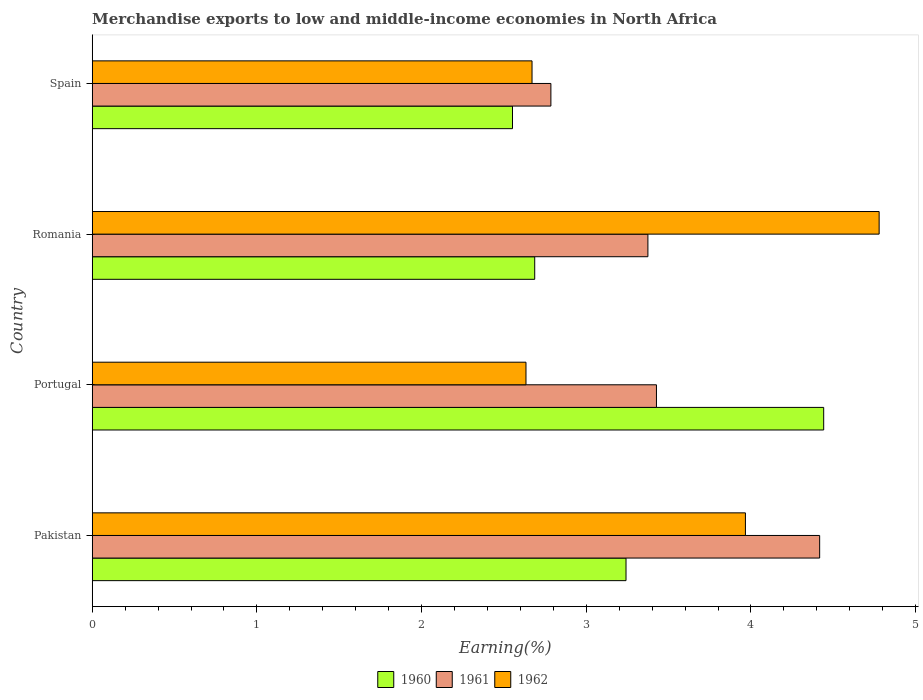How many different coloured bars are there?
Provide a succinct answer. 3. Are the number of bars per tick equal to the number of legend labels?
Your response must be concise. Yes. Are the number of bars on each tick of the Y-axis equal?
Provide a succinct answer. Yes. How many bars are there on the 1st tick from the top?
Your response must be concise. 3. How many bars are there on the 4th tick from the bottom?
Offer a very short reply. 3. What is the label of the 2nd group of bars from the top?
Provide a succinct answer. Romania. What is the percentage of amount earned from merchandise exports in 1960 in Romania?
Make the answer very short. 2.69. Across all countries, what is the maximum percentage of amount earned from merchandise exports in 1961?
Your response must be concise. 4.42. Across all countries, what is the minimum percentage of amount earned from merchandise exports in 1962?
Offer a very short reply. 2.63. What is the total percentage of amount earned from merchandise exports in 1961 in the graph?
Ensure brevity in your answer.  14. What is the difference between the percentage of amount earned from merchandise exports in 1961 in Pakistan and that in Portugal?
Offer a terse response. 0.99. What is the difference between the percentage of amount earned from merchandise exports in 1960 in Pakistan and the percentage of amount earned from merchandise exports in 1962 in Portugal?
Ensure brevity in your answer.  0.61. What is the average percentage of amount earned from merchandise exports in 1961 per country?
Your answer should be compact. 3.5. What is the difference between the percentage of amount earned from merchandise exports in 1961 and percentage of amount earned from merchandise exports in 1960 in Pakistan?
Your response must be concise. 1.18. What is the ratio of the percentage of amount earned from merchandise exports in 1960 in Pakistan to that in Spain?
Ensure brevity in your answer.  1.27. Is the percentage of amount earned from merchandise exports in 1961 in Pakistan less than that in Portugal?
Ensure brevity in your answer.  No. Is the difference between the percentage of amount earned from merchandise exports in 1961 in Pakistan and Romania greater than the difference between the percentage of amount earned from merchandise exports in 1960 in Pakistan and Romania?
Your answer should be very brief. Yes. What is the difference between the highest and the second highest percentage of amount earned from merchandise exports in 1962?
Keep it short and to the point. 0.81. What is the difference between the highest and the lowest percentage of amount earned from merchandise exports in 1962?
Provide a short and direct response. 2.14. In how many countries, is the percentage of amount earned from merchandise exports in 1960 greater than the average percentage of amount earned from merchandise exports in 1960 taken over all countries?
Keep it short and to the point. 2. What does the 1st bar from the top in Romania represents?
Your response must be concise. 1962. Is it the case that in every country, the sum of the percentage of amount earned from merchandise exports in 1960 and percentage of amount earned from merchandise exports in 1961 is greater than the percentage of amount earned from merchandise exports in 1962?
Your answer should be compact. Yes. How many countries are there in the graph?
Provide a short and direct response. 4. Does the graph contain any zero values?
Your answer should be compact. No. Does the graph contain grids?
Make the answer very short. No. Where does the legend appear in the graph?
Ensure brevity in your answer.  Bottom center. How are the legend labels stacked?
Your answer should be very brief. Horizontal. What is the title of the graph?
Your answer should be very brief. Merchandise exports to low and middle-income economies in North Africa. Does "1986" appear as one of the legend labels in the graph?
Your response must be concise. No. What is the label or title of the X-axis?
Provide a succinct answer. Earning(%). What is the label or title of the Y-axis?
Provide a short and direct response. Country. What is the Earning(%) of 1960 in Pakistan?
Offer a terse response. 3.24. What is the Earning(%) in 1961 in Pakistan?
Make the answer very short. 4.42. What is the Earning(%) in 1962 in Pakistan?
Your answer should be compact. 3.97. What is the Earning(%) in 1960 in Portugal?
Give a very brief answer. 4.44. What is the Earning(%) of 1961 in Portugal?
Your answer should be compact. 3.43. What is the Earning(%) in 1962 in Portugal?
Your answer should be very brief. 2.63. What is the Earning(%) of 1960 in Romania?
Your answer should be very brief. 2.69. What is the Earning(%) of 1961 in Romania?
Make the answer very short. 3.37. What is the Earning(%) of 1962 in Romania?
Offer a terse response. 4.78. What is the Earning(%) in 1960 in Spain?
Your response must be concise. 2.55. What is the Earning(%) in 1961 in Spain?
Keep it short and to the point. 2.79. What is the Earning(%) of 1962 in Spain?
Make the answer very short. 2.67. Across all countries, what is the maximum Earning(%) of 1960?
Your response must be concise. 4.44. Across all countries, what is the maximum Earning(%) in 1961?
Give a very brief answer. 4.42. Across all countries, what is the maximum Earning(%) in 1962?
Make the answer very short. 4.78. Across all countries, what is the minimum Earning(%) of 1960?
Offer a terse response. 2.55. Across all countries, what is the minimum Earning(%) in 1961?
Ensure brevity in your answer.  2.79. Across all countries, what is the minimum Earning(%) in 1962?
Provide a short and direct response. 2.63. What is the total Earning(%) of 1960 in the graph?
Provide a succinct answer. 12.92. What is the total Earning(%) of 1961 in the graph?
Keep it short and to the point. 14. What is the total Earning(%) of 1962 in the graph?
Offer a very short reply. 14.05. What is the difference between the Earning(%) in 1960 in Pakistan and that in Portugal?
Give a very brief answer. -1.2. What is the difference between the Earning(%) in 1962 in Pakistan and that in Portugal?
Make the answer very short. 1.33. What is the difference between the Earning(%) in 1960 in Pakistan and that in Romania?
Your response must be concise. 0.55. What is the difference between the Earning(%) of 1961 in Pakistan and that in Romania?
Keep it short and to the point. 1.04. What is the difference between the Earning(%) of 1962 in Pakistan and that in Romania?
Your answer should be compact. -0.81. What is the difference between the Earning(%) of 1960 in Pakistan and that in Spain?
Your answer should be very brief. 0.69. What is the difference between the Earning(%) in 1961 in Pakistan and that in Spain?
Keep it short and to the point. 1.63. What is the difference between the Earning(%) of 1962 in Pakistan and that in Spain?
Your answer should be very brief. 1.3. What is the difference between the Earning(%) of 1960 in Portugal and that in Romania?
Offer a very short reply. 1.75. What is the difference between the Earning(%) of 1961 in Portugal and that in Romania?
Provide a short and direct response. 0.05. What is the difference between the Earning(%) of 1962 in Portugal and that in Romania?
Your answer should be compact. -2.14. What is the difference between the Earning(%) in 1960 in Portugal and that in Spain?
Your response must be concise. 1.89. What is the difference between the Earning(%) of 1961 in Portugal and that in Spain?
Give a very brief answer. 0.64. What is the difference between the Earning(%) of 1962 in Portugal and that in Spain?
Give a very brief answer. -0.04. What is the difference between the Earning(%) in 1960 in Romania and that in Spain?
Your answer should be very brief. 0.13. What is the difference between the Earning(%) in 1961 in Romania and that in Spain?
Provide a short and direct response. 0.59. What is the difference between the Earning(%) in 1962 in Romania and that in Spain?
Provide a short and direct response. 2.11. What is the difference between the Earning(%) in 1960 in Pakistan and the Earning(%) in 1961 in Portugal?
Ensure brevity in your answer.  -0.18. What is the difference between the Earning(%) in 1960 in Pakistan and the Earning(%) in 1962 in Portugal?
Keep it short and to the point. 0.61. What is the difference between the Earning(%) of 1961 in Pakistan and the Earning(%) of 1962 in Portugal?
Provide a succinct answer. 1.78. What is the difference between the Earning(%) in 1960 in Pakistan and the Earning(%) in 1961 in Romania?
Ensure brevity in your answer.  -0.13. What is the difference between the Earning(%) in 1960 in Pakistan and the Earning(%) in 1962 in Romania?
Your response must be concise. -1.54. What is the difference between the Earning(%) of 1961 in Pakistan and the Earning(%) of 1962 in Romania?
Your answer should be very brief. -0.36. What is the difference between the Earning(%) of 1960 in Pakistan and the Earning(%) of 1961 in Spain?
Offer a terse response. 0.46. What is the difference between the Earning(%) in 1960 in Pakistan and the Earning(%) in 1962 in Spain?
Keep it short and to the point. 0.57. What is the difference between the Earning(%) of 1961 in Pakistan and the Earning(%) of 1962 in Spain?
Make the answer very short. 1.75. What is the difference between the Earning(%) of 1960 in Portugal and the Earning(%) of 1961 in Romania?
Give a very brief answer. 1.07. What is the difference between the Earning(%) in 1960 in Portugal and the Earning(%) in 1962 in Romania?
Your answer should be very brief. -0.34. What is the difference between the Earning(%) of 1961 in Portugal and the Earning(%) of 1962 in Romania?
Offer a terse response. -1.35. What is the difference between the Earning(%) of 1960 in Portugal and the Earning(%) of 1961 in Spain?
Make the answer very short. 1.66. What is the difference between the Earning(%) of 1960 in Portugal and the Earning(%) of 1962 in Spain?
Your response must be concise. 1.77. What is the difference between the Earning(%) of 1961 in Portugal and the Earning(%) of 1962 in Spain?
Give a very brief answer. 0.76. What is the difference between the Earning(%) of 1960 in Romania and the Earning(%) of 1961 in Spain?
Keep it short and to the point. -0.1. What is the difference between the Earning(%) in 1960 in Romania and the Earning(%) in 1962 in Spain?
Your answer should be very brief. 0.02. What is the difference between the Earning(%) of 1961 in Romania and the Earning(%) of 1962 in Spain?
Your response must be concise. 0.7. What is the average Earning(%) in 1960 per country?
Provide a succinct answer. 3.23. What is the average Earning(%) in 1961 per country?
Provide a short and direct response. 3.5. What is the average Earning(%) of 1962 per country?
Make the answer very short. 3.51. What is the difference between the Earning(%) of 1960 and Earning(%) of 1961 in Pakistan?
Your answer should be compact. -1.18. What is the difference between the Earning(%) in 1960 and Earning(%) in 1962 in Pakistan?
Ensure brevity in your answer.  -0.73. What is the difference between the Earning(%) in 1961 and Earning(%) in 1962 in Pakistan?
Provide a succinct answer. 0.45. What is the difference between the Earning(%) in 1960 and Earning(%) in 1961 in Portugal?
Offer a terse response. 1.02. What is the difference between the Earning(%) of 1960 and Earning(%) of 1962 in Portugal?
Your response must be concise. 1.81. What is the difference between the Earning(%) in 1961 and Earning(%) in 1962 in Portugal?
Provide a short and direct response. 0.79. What is the difference between the Earning(%) in 1960 and Earning(%) in 1961 in Romania?
Your response must be concise. -0.69. What is the difference between the Earning(%) in 1960 and Earning(%) in 1962 in Romania?
Offer a very short reply. -2.09. What is the difference between the Earning(%) in 1961 and Earning(%) in 1962 in Romania?
Offer a very short reply. -1.4. What is the difference between the Earning(%) in 1960 and Earning(%) in 1961 in Spain?
Offer a very short reply. -0.23. What is the difference between the Earning(%) of 1960 and Earning(%) of 1962 in Spain?
Offer a terse response. -0.12. What is the difference between the Earning(%) in 1961 and Earning(%) in 1962 in Spain?
Make the answer very short. 0.11. What is the ratio of the Earning(%) in 1960 in Pakistan to that in Portugal?
Provide a short and direct response. 0.73. What is the ratio of the Earning(%) of 1961 in Pakistan to that in Portugal?
Keep it short and to the point. 1.29. What is the ratio of the Earning(%) of 1962 in Pakistan to that in Portugal?
Make the answer very short. 1.51. What is the ratio of the Earning(%) in 1960 in Pakistan to that in Romania?
Keep it short and to the point. 1.21. What is the ratio of the Earning(%) in 1961 in Pakistan to that in Romania?
Offer a terse response. 1.31. What is the ratio of the Earning(%) in 1962 in Pakistan to that in Romania?
Your response must be concise. 0.83. What is the ratio of the Earning(%) of 1960 in Pakistan to that in Spain?
Offer a very short reply. 1.27. What is the ratio of the Earning(%) of 1961 in Pakistan to that in Spain?
Provide a short and direct response. 1.59. What is the ratio of the Earning(%) in 1962 in Pakistan to that in Spain?
Your answer should be compact. 1.49. What is the ratio of the Earning(%) of 1960 in Portugal to that in Romania?
Keep it short and to the point. 1.65. What is the ratio of the Earning(%) of 1961 in Portugal to that in Romania?
Ensure brevity in your answer.  1.02. What is the ratio of the Earning(%) of 1962 in Portugal to that in Romania?
Your answer should be compact. 0.55. What is the ratio of the Earning(%) in 1960 in Portugal to that in Spain?
Give a very brief answer. 1.74. What is the ratio of the Earning(%) in 1961 in Portugal to that in Spain?
Ensure brevity in your answer.  1.23. What is the ratio of the Earning(%) in 1962 in Portugal to that in Spain?
Provide a short and direct response. 0.99. What is the ratio of the Earning(%) of 1960 in Romania to that in Spain?
Offer a very short reply. 1.05. What is the ratio of the Earning(%) of 1961 in Romania to that in Spain?
Provide a short and direct response. 1.21. What is the ratio of the Earning(%) in 1962 in Romania to that in Spain?
Give a very brief answer. 1.79. What is the difference between the highest and the second highest Earning(%) in 1960?
Your answer should be very brief. 1.2. What is the difference between the highest and the second highest Earning(%) in 1962?
Your response must be concise. 0.81. What is the difference between the highest and the lowest Earning(%) in 1960?
Keep it short and to the point. 1.89. What is the difference between the highest and the lowest Earning(%) in 1961?
Ensure brevity in your answer.  1.63. What is the difference between the highest and the lowest Earning(%) in 1962?
Your answer should be compact. 2.14. 